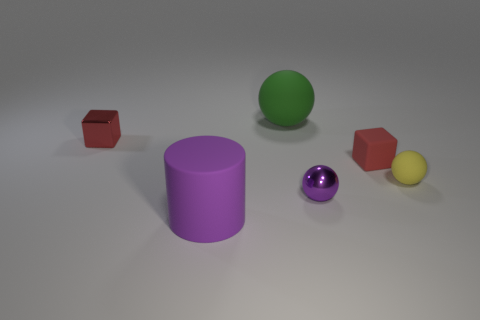There is a rubber cylinder that is the same color as the metal ball; what is its size?
Your answer should be compact. Large. How many red things are either tiny objects or metallic balls?
Offer a very short reply. 2. What number of other objects are there of the same shape as the tiny yellow thing?
Ensure brevity in your answer.  2. What is the shape of the rubber thing that is behind the yellow thing and on the left side of the purple shiny object?
Your answer should be compact. Sphere. Are there any tiny red rubber blocks on the right side of the large green rubber object?
Provide a short and direct response. Yes. There is a green rubber thing that is the same shape as the tiny yellow thing; what size is it?
Your answer should be very brief. Large. Does the yellow matte thing have the same shape as the red shiny thing?
Provide a succinct answer. No. There is a object in front of the sphere in front of the yellow ball; what size is it?
Your answer should be compact. Large. There is a metallic object that is the same shape as the yellow rubber object; what color is it?
Provide a succinct answer. Purple. How many other blocks are the same color as the shiny block?
Give a very brief answer. 1. 